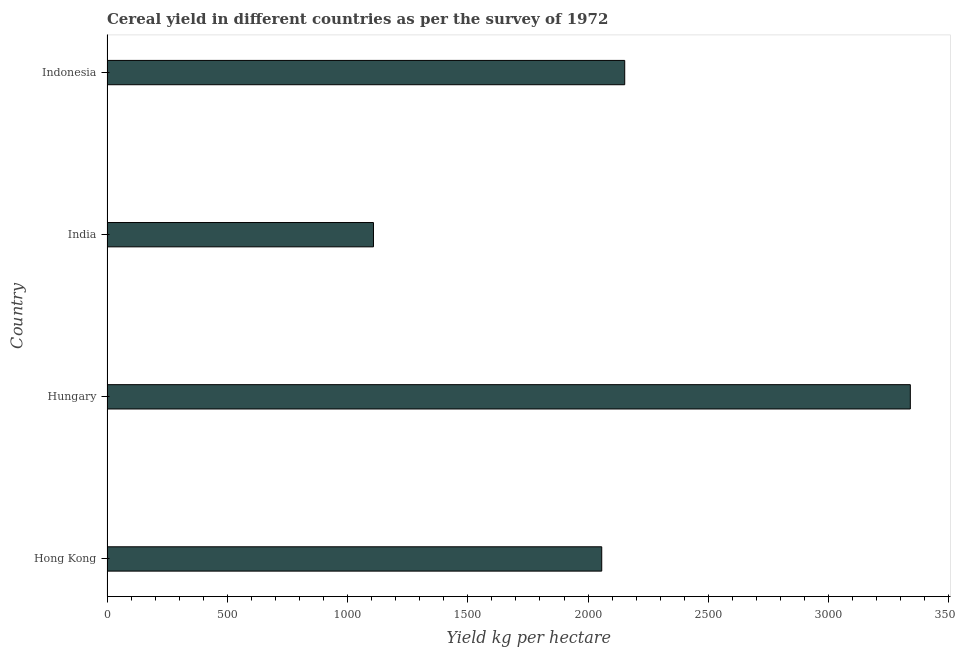Does the graph contain any zero values?
Your answer should be compact. No. Does the graph contain grids?
Your answer should be very brief. No. What is the title of the graph?
Offer a very short reply. Cereal yield in different countries as per the survey of 1972. What is the label or title of the X-axis?
Make the answer very short. Yield kg per hectare. What is the label or title of the Y-axis?
Provide a short and direct response. Country. What is the cereal yield in Hungary?
Make the answer very short. 3339.77. Across all countries, what is the maximum cereal yield?
Your response must be concise. 3339.77. Across all countries, what is the minimum cereal yield?
Provide a succinct answer. 1107.83. In which country was the cereal yield maximum?
Ensure brevity in your answer.  Hungary. In which country was the cereal yield minimum?
Provide a succinct answer. India. What is the sum of the cereal yield?
Provide a short and direct response. 8656.77. What is the difference between the cereal yield in Hong Kong and Hungary?
Make the answer very short. -1282.97. What is the average cereal yield per country?
Provide a short and direct response. 2164.19. What is the median cereal yield?
Provide a short and direct response. 2104.59. In how many countries, is the cereal yield greater than 3200 kg per hectare?
Your answer should be compact. 1. What is the ratio of the cereal yield in Hong Kong to that in Indonesia?
Your answer should be compact. 0.96. Is the difference between the cereal yield in Hong Kong and Hungary greater than the difference between any two countries?
Your response must be concise. No. What is the difference between the highest and the second highest cereal yield?
Provide a short and direct response. 1187.39. Is the sum of the cereal yield in India and Indonesia greater than the maximum cereal yield across all countries?
Your answer should be very brief. No. What is the difference between the highest and the lowest cereal yield?
Offer a very short reply. 2231.94. Are the values on the major ticks of X-axis written in scientific E-notation?
Provide a short and direct response. No. What is the Yield kg per hectare of Hong Kong?
Ensure brevity in your answer.  2056.8. What is the Yield kg per hectare in Hungary?
Provide a short and direct response. 3339.77. What is the Yield kg per hectare in India?
Your response must be concise. 1107.83. What is the Yield kg per hectare in Indonesia?
Ensure brevity in your answer.  2152.38. What is the difference between the Yield kg per hectare in Hong Kong and Hungary?
Your response must be concise. -1282.97. What is the difference between the Yield kg per hectare in Hong Kong and India?
Keep it short and to the point. 948.97. What is the difference between the Yield kg per hectare in Hong Kong and Indonesia?
Make the answer very short. -95.58. What is the difference between the Yield kg per hectare in Hungary and India?
Give a very brief answer. 2231.94. What is the difference between the Yield kg per hectare in Hungary and Indonesia?
Your answer should be very brief. 1187.39. What is the difference between the Yield kg per hectare in India and Indonesia?
Make the answer very short. -1044.56. What is the ratio of the Yield kg per hectare in Hong Kong to that in Hungary?
Provide a short and direct response. 0.62. What is the ratio of the Yield kg per hectare in Hong Kong to that in India?
Keep it short and to the point. 1.86. What is the ratio of the Yield kg per hectare in Hong Kong to that in Indonesia?
Offer a terse response. 0.96. What is the ratio of the Yield kg per hectare in Hungary to that in India?
Keep it short and to the point. 3.02. What is the ratio of the Yield kg per hectare in Hungary to that in Indonesia?
Ensure brevity in your answer.  1.55. What is the ratio of the Yield kg per hectare in India to that in Indonesia?
Provide a succinct answer. 0.52. 